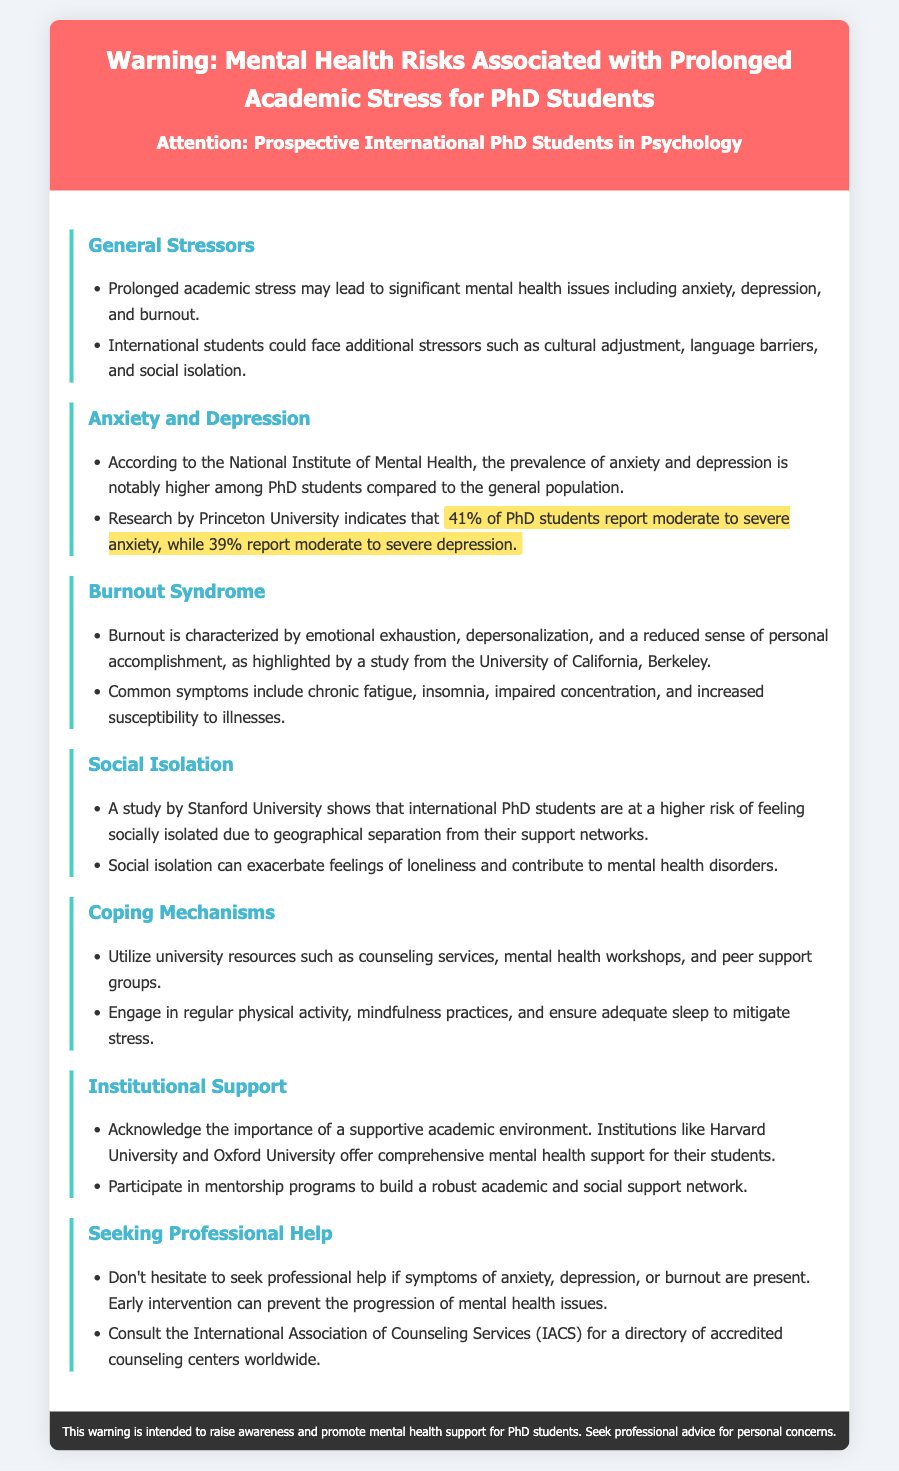what is the percentage of PhD students reporting moderate to severe anxiety? The document states that 41% of PhD students report moderate to severe anxiety.
Answer: 41% what is a common symptom of burnout? The document lists chronic fatigue as a common symptom of burnout.
Answer: chronic fatigue which universities offer comprehensive mental health support? The document mentions Harvard University and Oxford University as institutions offering support.
Answer: Harvard University and Oxford University what is the prevalence of depression among PhD students according to the document? The document indicates that 39% of PhD students report moderate to severe depression.
Answer: 39% what should students utilize to cope with stress? The document advises using counseling services and peer support groups.
Answer: counseling services, peer support groups what is a unique risk for international PhD students? The document highlights social isolation as a unique risk for international PhD students.
Answer: social isolation what does the document recommend for mitigating stress? The document suggests engaging in regular physical activity.
Answer: regular physical activity what is one reason international students may experience additional stress? The document states that cultural adjustment is a reason for additional stress.
Answer: cultural adjustment 